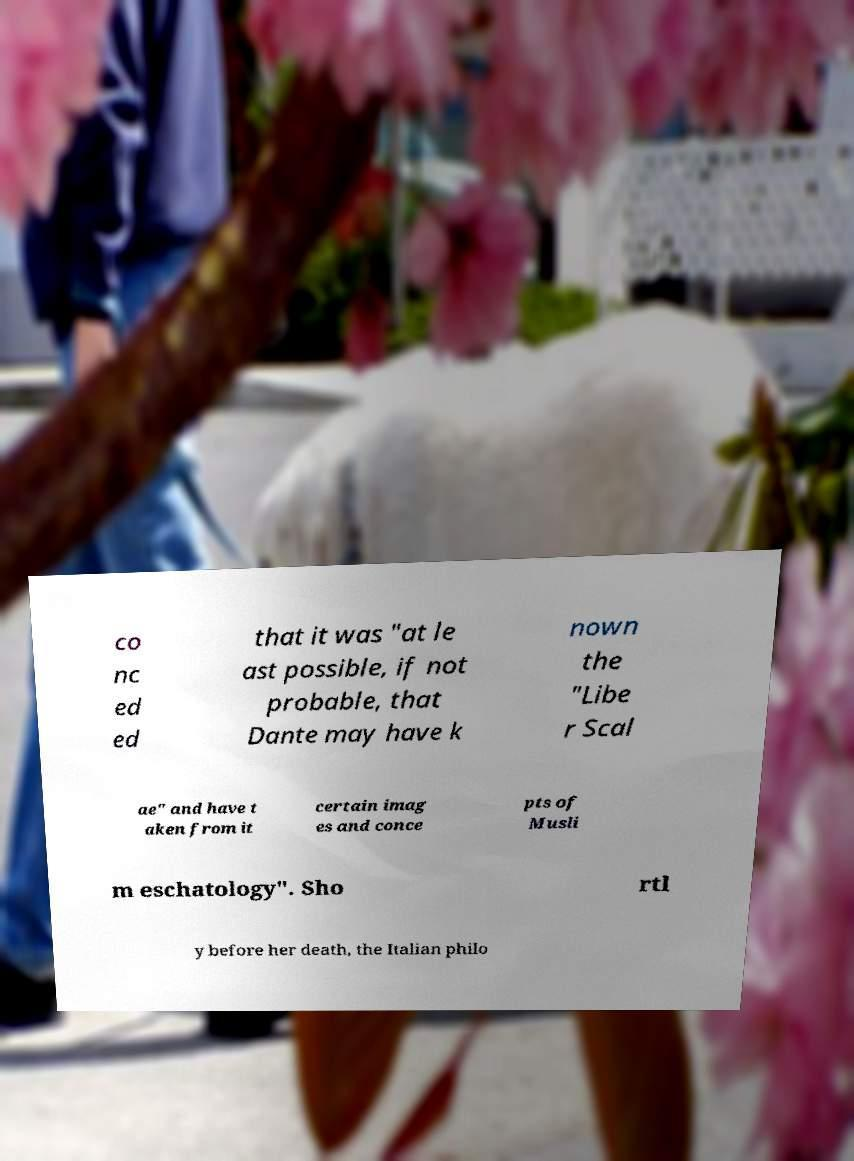For documentation purposes, I need the text within this image transcribed. Could you provide that? co nc ed ed that it was "at le ast possible, if not probable, that Dante may have k nown the "Libe r Scal ae" and have t aken from it certain imag es and conce pts of Musli m eschatology". Sho rtl y before her death, the Italian philo 